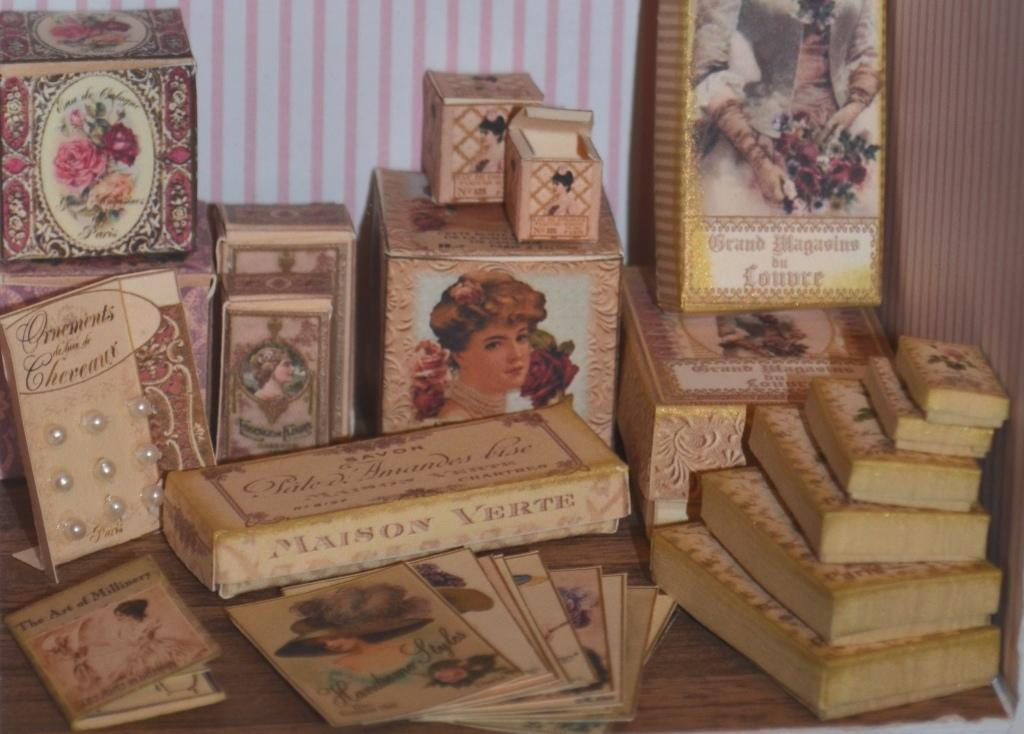Provide a one-sentence caption for the provided image. Various books sit on a table like Grand Magasins bu Lonure. 